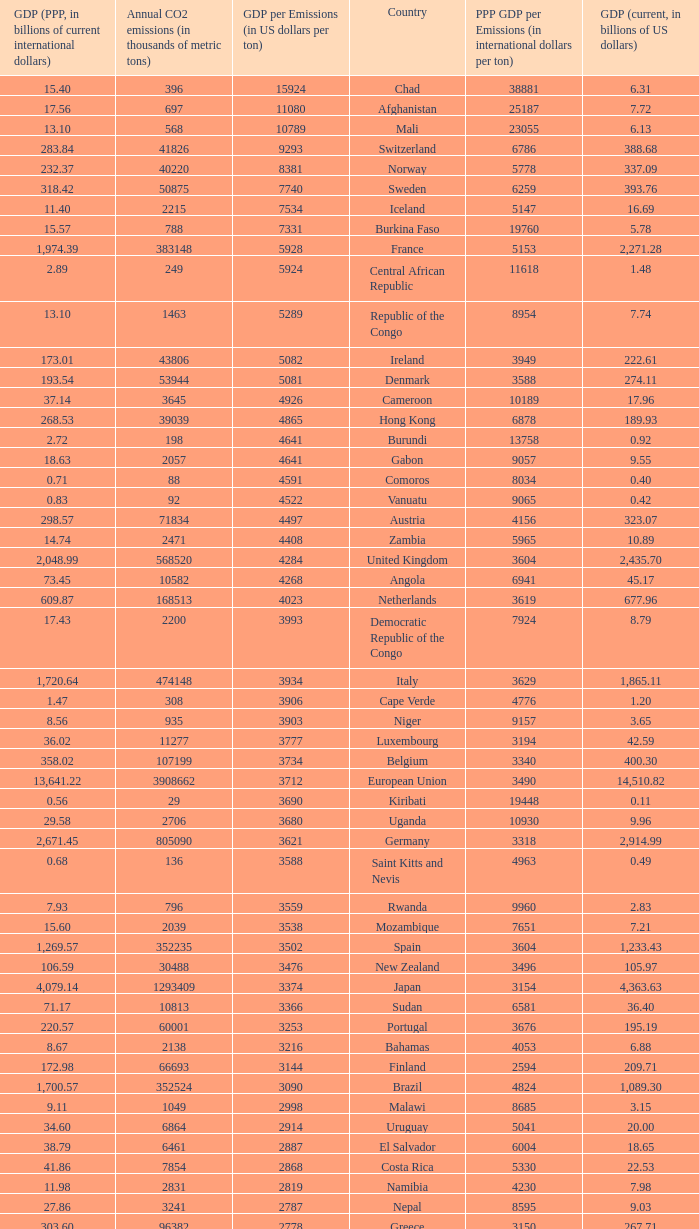50, what is the gdp? 2562.0. 